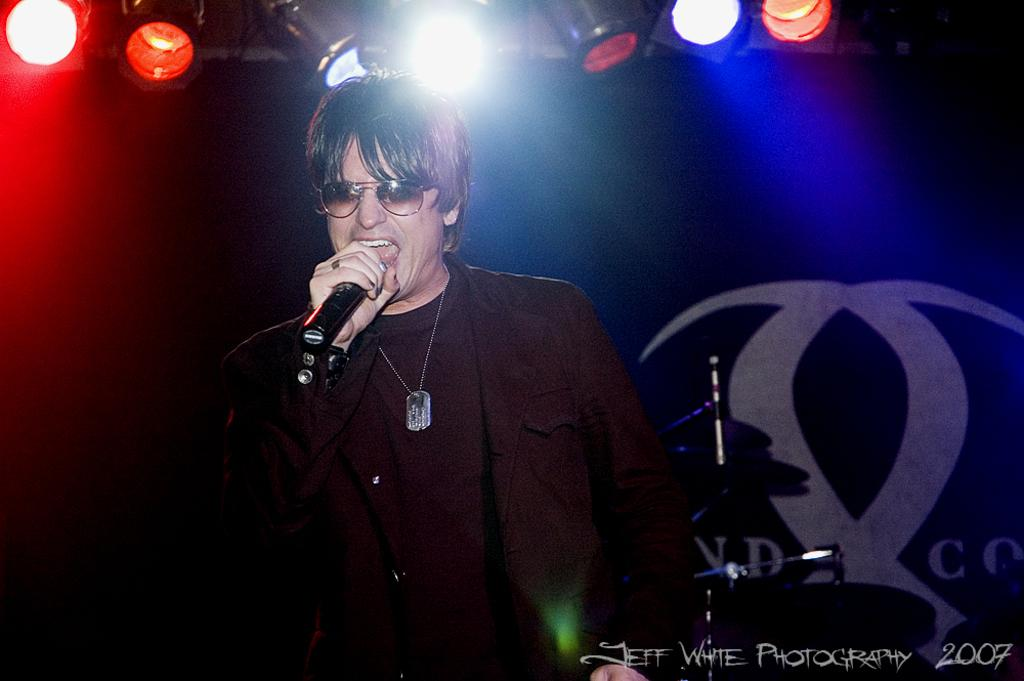What is the man in the image doing? The man is standing and singing a song in the image. What is the man holding while singing? The man is holding a microphone. What can be seen at the top of the image? Show lights are visible at the top of the image. What else can be seen in the background of the image? There are instruments in the background of the image. How many friends is the man singing with in the image? The provided facts do not mention any friends in the image, so we cannot determine the number of friends the man is singing with. 